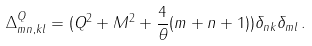Convert formula to latex. <formula><loc_0><loc_0><loc_500><loc_500>\Delta ^ { Q } _ { m n , k l } = ( Q ^ { 2 } + M ^ { 2 } + \frac { 4 } { \theta } ( m + n + 1 ) ) \delta _ { n k } \delta _ { m l } \, .</formula> 